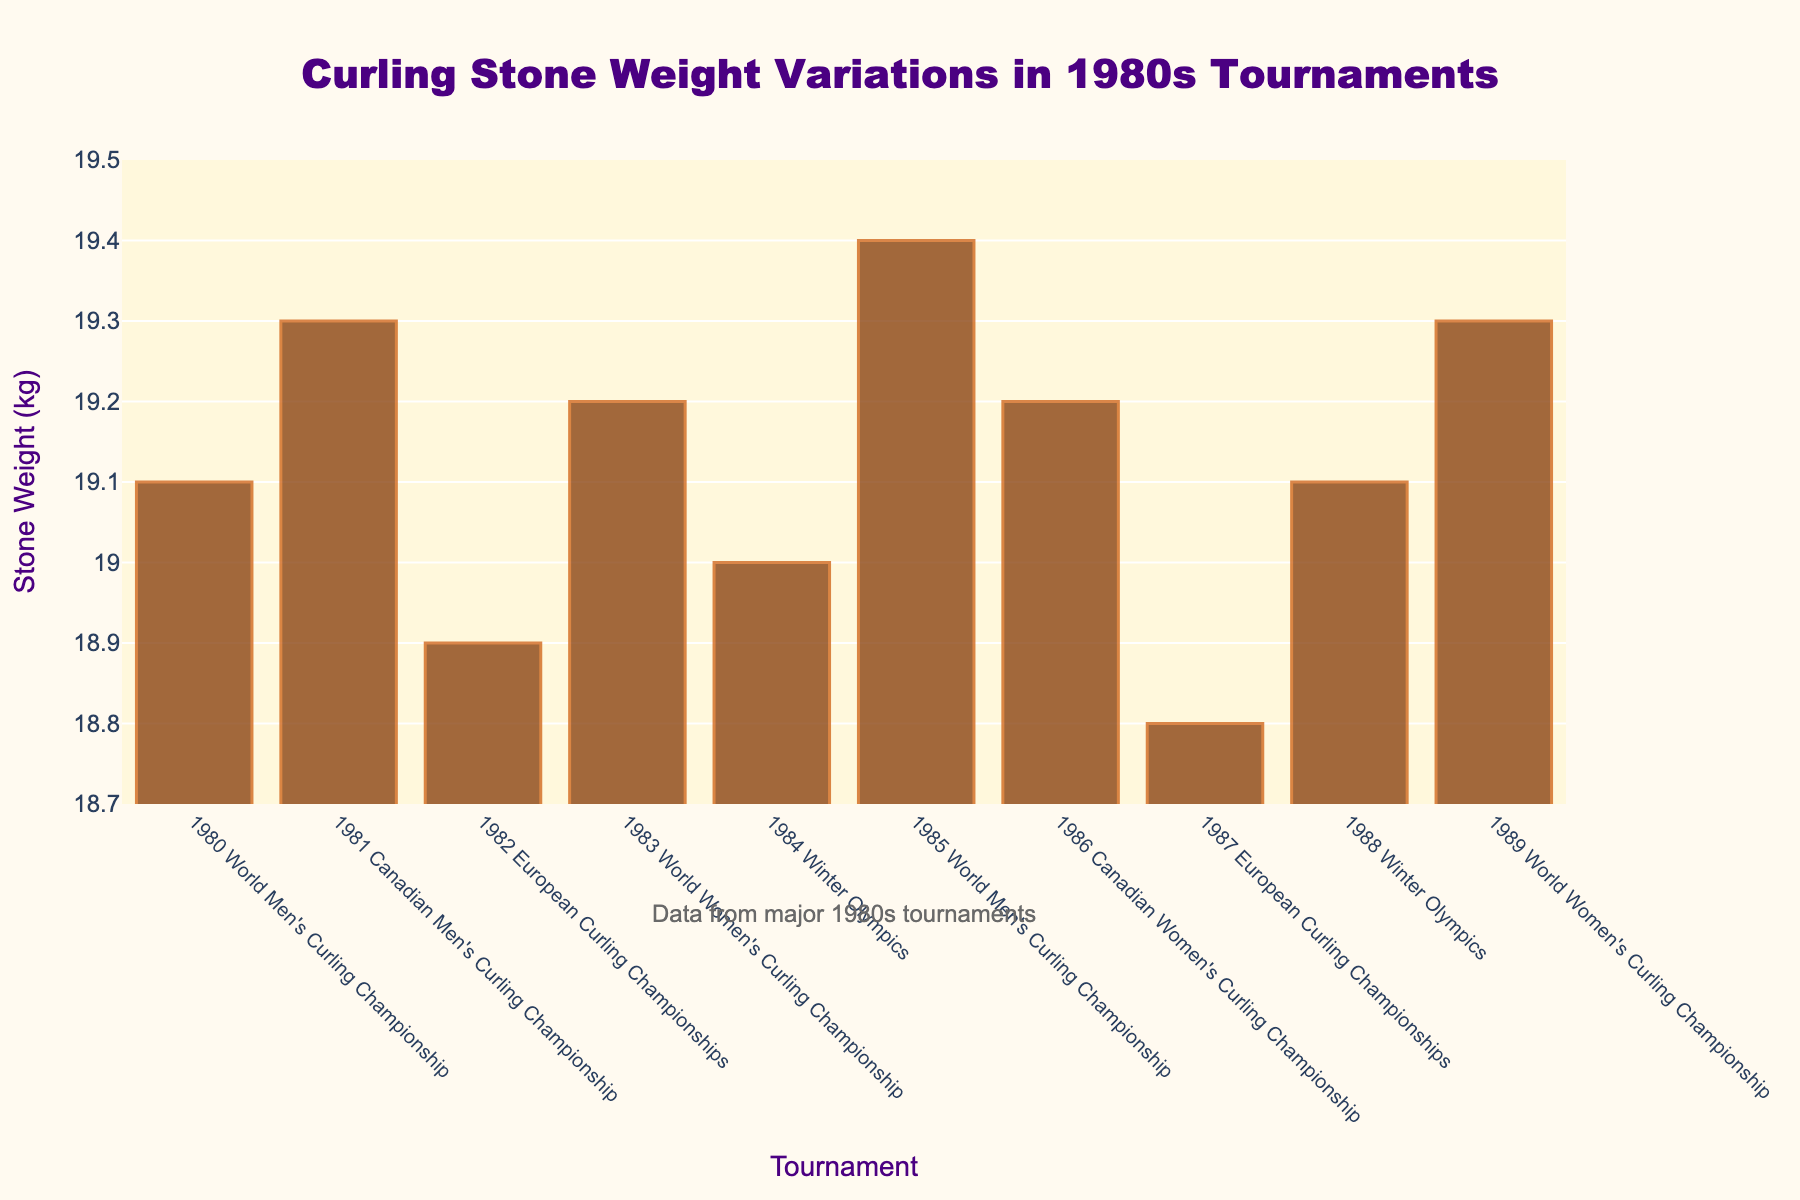What's the average stone weight across all tournaments? To calculate the average, sum up the stone weights from each tournament: 19.1 + 19.3 + 18.9 + 19.2 + 19.0 + 19.4 + 19.2 + 18.8 + 19.1 + 19.3 = 191.3 kg. Then, divide this sum by the number of tournaments (10): 191.3 / 10 = 19.13 kg
Answer: 19.13 kg Which tournament had the heaviest curling stone weight, and what was that weight? By examining the bar chart, identify the tallest bar which represents the heaviest stone weight. The tallest bar corresponds to the 1985 World Men's Curling Championship with a stone weight of 19.4 kg.
Answer: 1985 World Men's Curling Championship, 19.4 kg Which tournament had the lightest curling stone weight, and what was that weight? By locating the shortest bar in the chart, we identify the 1987 European Curling Championships as the tournament with the lightest stone weight at 18.8 kg.
Answer: 1987 European Curling Championships, 18.8 kg What is the difference between the heaviest and lightest curling stone weights? First, find the heaviest stone weight (19.4 kg) and the lightest stone weight (18.8 kg). Then compute the difference: 19.4 - 18.8 = 0.6 kg.
Answer: 0.6 kg How many tournaments had a curling stone weight greater than 19 kg? From the bar chart, count the number of bars with heights representing weights greater than 19 kg. These tournaments are 1980, 1981, 1983, 1985, 1986, 1988, and 1989, resulting in 7 tournaments.
Answer: 7 Which years had curling stone weights exactly equal to 19.2 kg? By inspecting the bar heights corresponding to a weight of 19.2 kg, identify the years 1983 and 1986.
Answer: 1983 and 1986 What's the median curling stone weight across the tournaments? List all weights in ascending order: 18.8, 18.9, 19.0, 19.1, 19.1, 19.2, 19.2, 19.3, 19.3, 19.4. The median is the average of the 5th and 6th values: (19.1 + 19.2) / 2 = 19.15 kg.
Answer: 19.15 kg What was the stone weight used in the 1984 Winter Olympics, and how does it compare to the average weight? The stone weight in the 1984 Winter Olympics is 19.0 kg. The average weight is 19.13 kg. Comparing the two, 19.0 kg is less than 19.13 kg.
Answer: 19.0 kg, less than average 